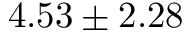Convert formula to latex. <formula><loc_0><loc_0><loc_500><loc_500>4 . 5 3 \pm 2 . 2 8</formula> 